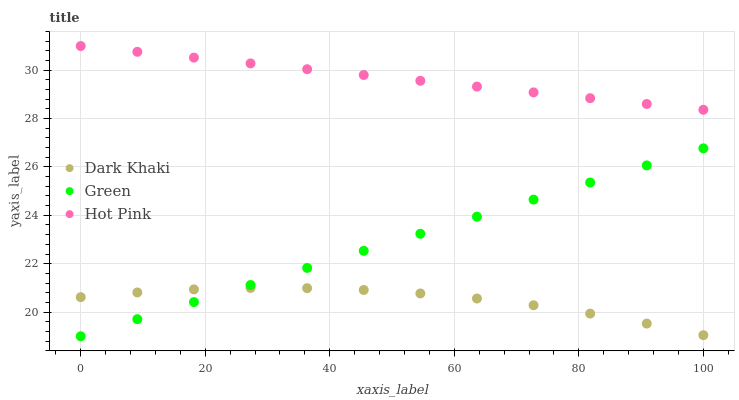Does Dark Khaki have the minimum area under the curve?
Answer yes or no. Yes. Does Hot Pink have the maximum area under the curve?
Answer yes or no. Yes. Does Green have the minimum area under the curve?
Answer yes or no. No. Does Green have the maximum area under the curve?
Answer yes or no. No. Is Hot Pink the smoothest?
Answer yes or no. Yes. Is Dark Khaki the roughest?
Answer yes or no. Yes. Is Green the smoothest?
Answer yes or no. No. Is Green the roughest?
Answer yes or no. No. Does Green have the lowest value?
Answer yes or no. Yes. Does Hot Pink have the lowest value?
Answer yes or no. No. Does Hot Pink have the highest value?
Answer yes or no. Yes. Does Green have the highest value?
Answer yes or no. No. Is Green less than Hot Pink?
Answer yes or no. Yes. Is Hot Pink greater than Dark Khaki?
Answer yes or no. Yes. Does Green intersect Dark Khaki?
Answer yes or no. Yes. Is Green less than Dark Khaki?
Answer yes or no. No. Is Green greater than Dark Khaki?
Answer yes or no. No. Does Green intersect Hot Pink?
Answer yes or no. No. 